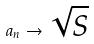Convert formula to latex. <formula><loc_0><loc_0><loc_500><loc_500>a _ { n } \rightarrow \sqrt { S }</formula> 